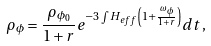Convert formula to latex. <formula><loc_0><loc_0><loc_500><loc_500>\rho _ { \phi } = \frac { \rho _ { \phi _ { 0 } } } { 1 + r } e ^ { - 3 \int H _ { e f f } \left ( 1 + \frac { \omega _ { \phi } } { 1 + r } \right ) } d t \, ,</formula> 